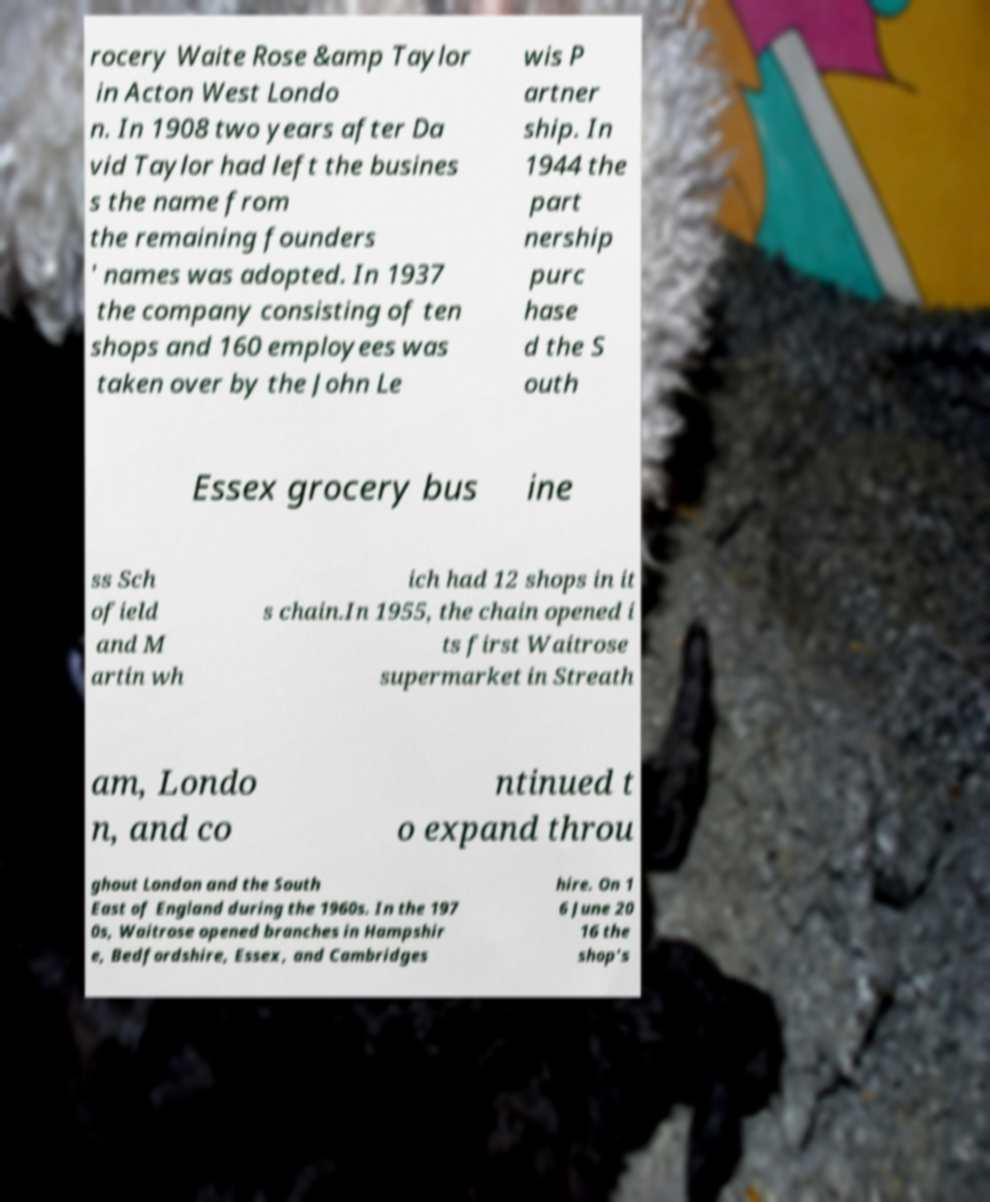I need the written content from this picture converted into text. Can you do that? rocery Waite Rose &amp Taylor in Acton West Londo n. In 1908 two years after Da vid Taylor had left the busines s the name from the remaining founders ' names was adopted. In 1937 the company consisting of ten shops and 160 employees was taken over by the John Le wis P artner ship. In 1944 the part nership purc hase d the S outh Essex grocery bus ine ss Sch ofield and M artin wh ich had 12 shops in it s chain.In 1955, the chain opened i ts first Waitrose supermarket in Streath am, Londo n, and co ntinued t o expand throu ghout London and the South East of England during the 1960s. In the 197 0s, Waitrose opened branches in Hampshir e, Bedfordshire, Essex, and Cambridges hire. On 1 6 June 20 16 the shop's 